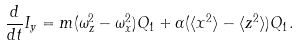Convert formula to latex. <formula><loc_0><loc_0><loc_500><loc_500>\frac { d } { d t } I _ { y } = m ( \omega _ { z } ^ { 2 } - \omega _ { x } ^ { 2 } ) Q _ { 1 } + \alpha ( \langle x ^ { 2 } \rangle - \langle z ^ { 2 } \rangle ) Q _ { 1 } .</formula> 